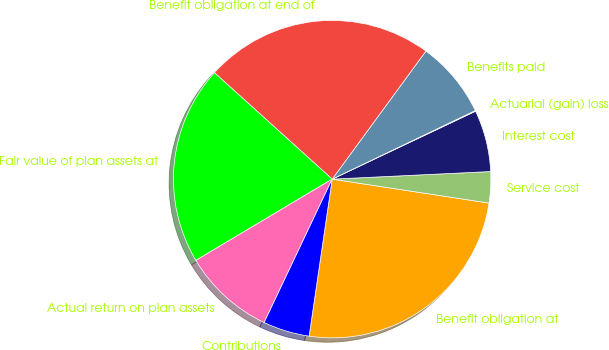Convert chart to OTSL. <chart><loc_0><loc_0><loc_500><loc_500><pie_chart><fcel>Benefit obligation at<fcel>Service cost<fcel>Interest cost<fcel>Actuarial (gain) loss<fcel>Benefits paid<fcel>Benefit obligation at end of<fcel>Fair value of plan assets at<fcel>Actual return on plan assets<fcel>Contributions<nl><fcel>24.91%<fcel>3.17%<fcel>6.28%<fcel>0.07%<fcel>7.83%<fcel>23.36%<fcel>20.26%<fcel>9.39%<fcel>4.73%<nl></chart> 